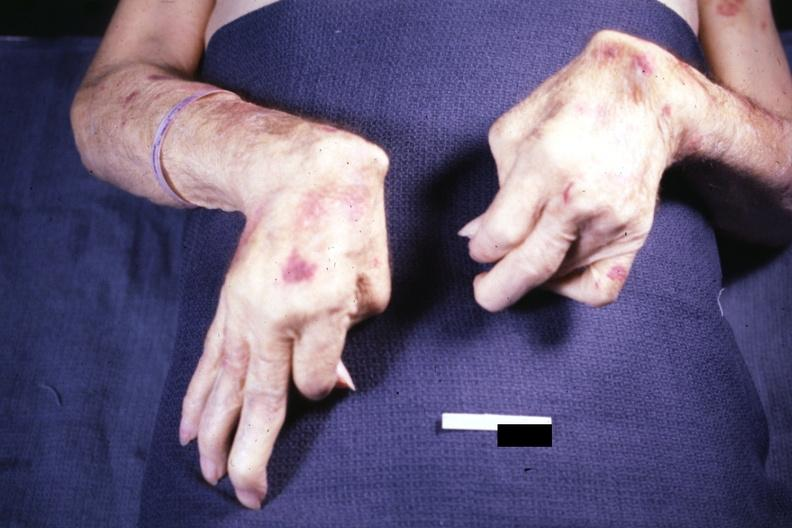what does this image show?
Answer the question using a single word or phrase. Good example exposure not the best but ok rheumatoid arthritis 